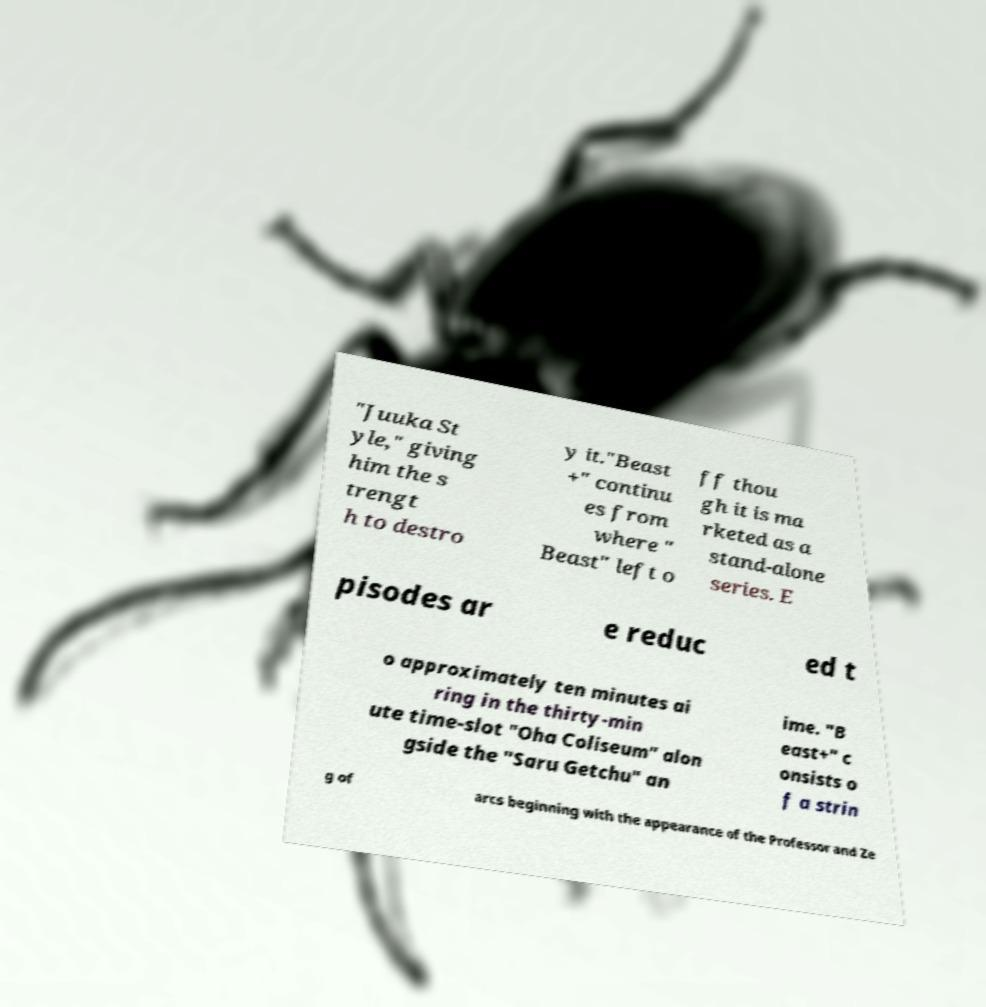What messages or text are displayed in this image? I need them in a readable, typed format. "Juuka St yle," giving him the s trengt h to destro y it."Beast +" continu es from where " Beast" left o ff thou gh it is ma rketed as a stand-alone series. E pisodes ar e reduc ed t o approximately ten minutes ai ring in the thirty-min ute time-slot "Oha Coliseum" alon gside the "Saru Getchu" an ime. "B east+" c onsists o f a strin g of arcs beginning with the appearance of the Professor and Ze 